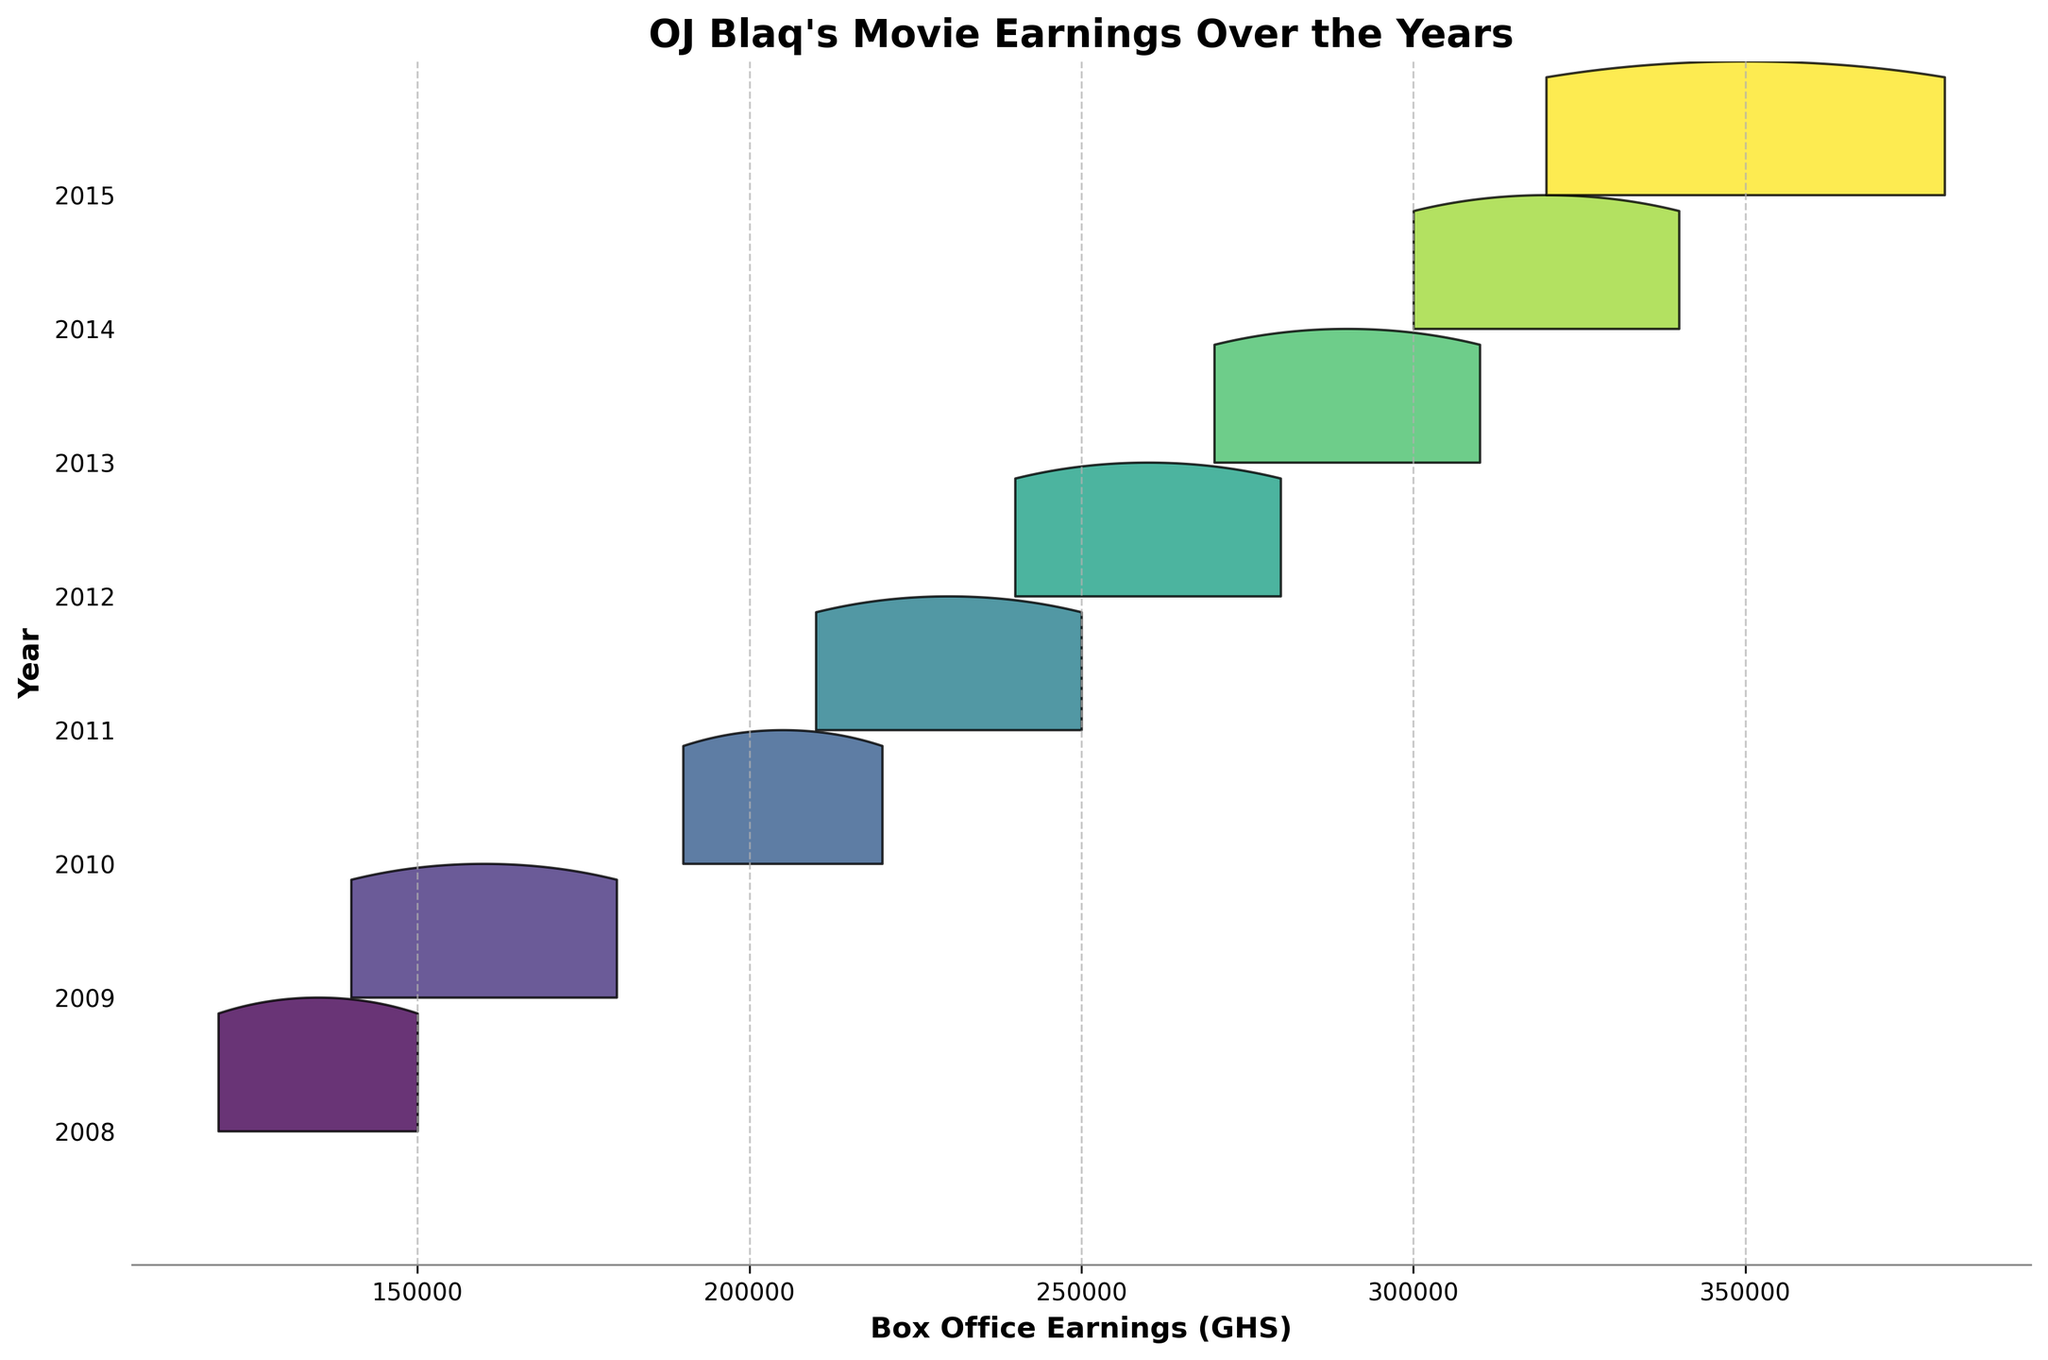What is the title of the plot? The title is typically placed at the top of the plot and serves as a summary of what the plot represents. In this case, the plot shows the earnings of movies featuring OJ Blaq over different years.
Answer: OJ Blaq's Movie Earnings Over the Years What does the x-axis represent? The x-axis is labeled and indicates what values are plotted along it. Here, the x-axis represents the Box Office Earnings in Ghanaian Cedi (GHS).
Answer: Box Office Earnings (GHS) Which year has the highest median box office earnings? Look along the y-axis to identify the year with the peak closest to the top. A peak higher on the ridgeline plot corresponds to a higher median value.
Answer: 2015 Which year shows the largest spread in box office earnings? Analyze the width of the ridges for each year. A wider ridge indicates a larger spread in earnings for that year.
Answer: 2015 In which year did the lowest earnings occur, and what was that amount? Identify the bottom-most point on the ridgeline plot and trace it back to the y-axis to find the corresponding year and then read off the lowest x-axis value for that ridge.
Answer: 2008, 120000 GHS Between 2011 and 2015, which year had the highest maximum earnings? Compare the ridges for each of the years between 2011 and 2015 and determine which one extends furthest to the right on the x-axis.
Answer: 2015 What is the trend in median box office earnings from 2008 to 2015? Observe the central peaks of the ridges from 2008 to 2015. Notice whether the peaks show an increasing trend, decreasing trend, or are relatively constant over the years.
Answer: Increasing How many movies are represented in the year 2010? Count the number of peaks within the ridge corresponding to the year 2010 to determine the number of distinct movies.
Answer: 2 Compare the earnings range in 2009 to that in 2013. Which year had a wider range? The earnings range can be visually estimated by the width of the ridges for both years. The wider ridge represents a larger range of earnings.
Answer: 2013 What is the average box office earnings in 2014 and how does it compare to the earnings in 2008? Calculate the mean of the earnings for the movies released in 2014 and compare it to the values from 2008.
Answer: 320000 GHS in 2014, higher compared to 2008 